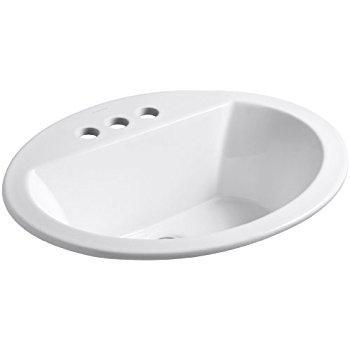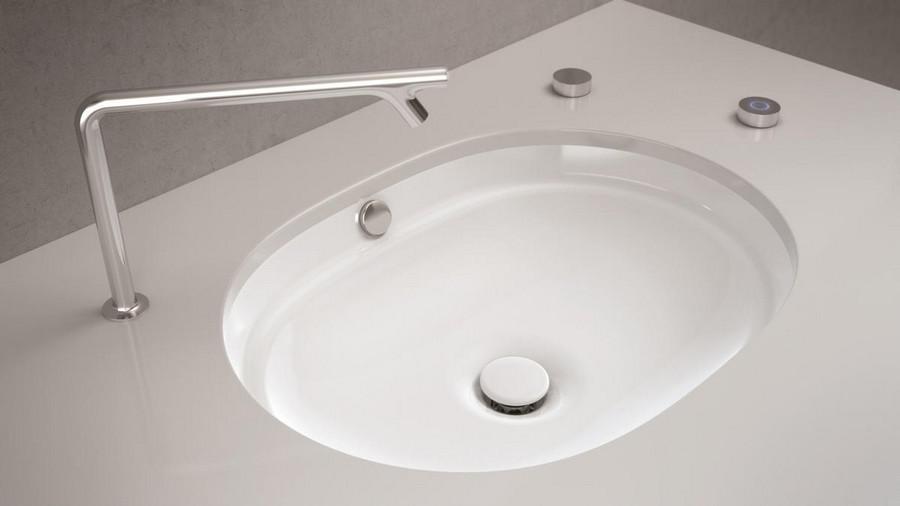The first image is the image on the left, the second image is the image on the right. For the images displayed, is the sentence "the sinks is square in the right pic" factually correct? Answer yes or no. No. 